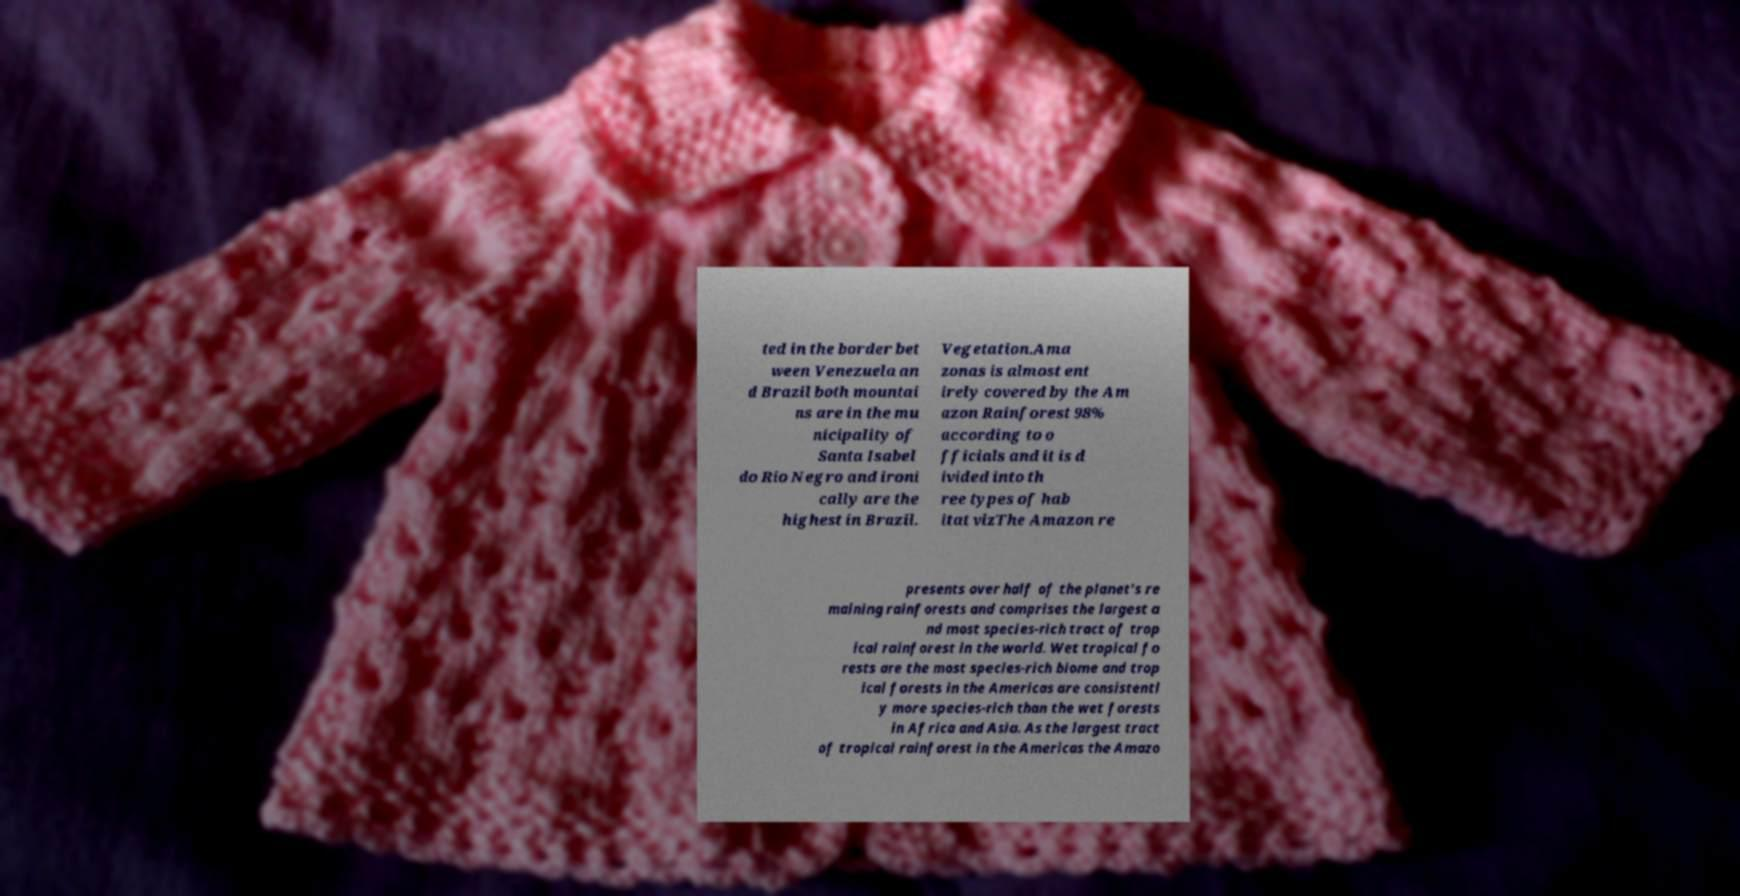Please read and relay the text visible in this image. What does it say? ted in the border bet ween Venezuela an d Brazil both mountai ns are in the mu nicipality of Santa Isabel do Rio Negro and ironi cally are the highest in Brazil. Vegetation.Ama zonas is almost ent irely covered by the Am azon Rainforest 98% according to o fficials and it is d ivided into th ree types of hab itat vizThe Amazon re presents over half of the planet's re maining rainforests and comprises the largest a nd most species-rich tract of trop ical rainforest in the world. Wet tropical fo rests are the most species-rich biome and trop ical forests in the Americas are consistentl y more species-rich than the wet forests in Africa and Asia. As the largest tract of tropical rainforest in the Americas the Amazo 